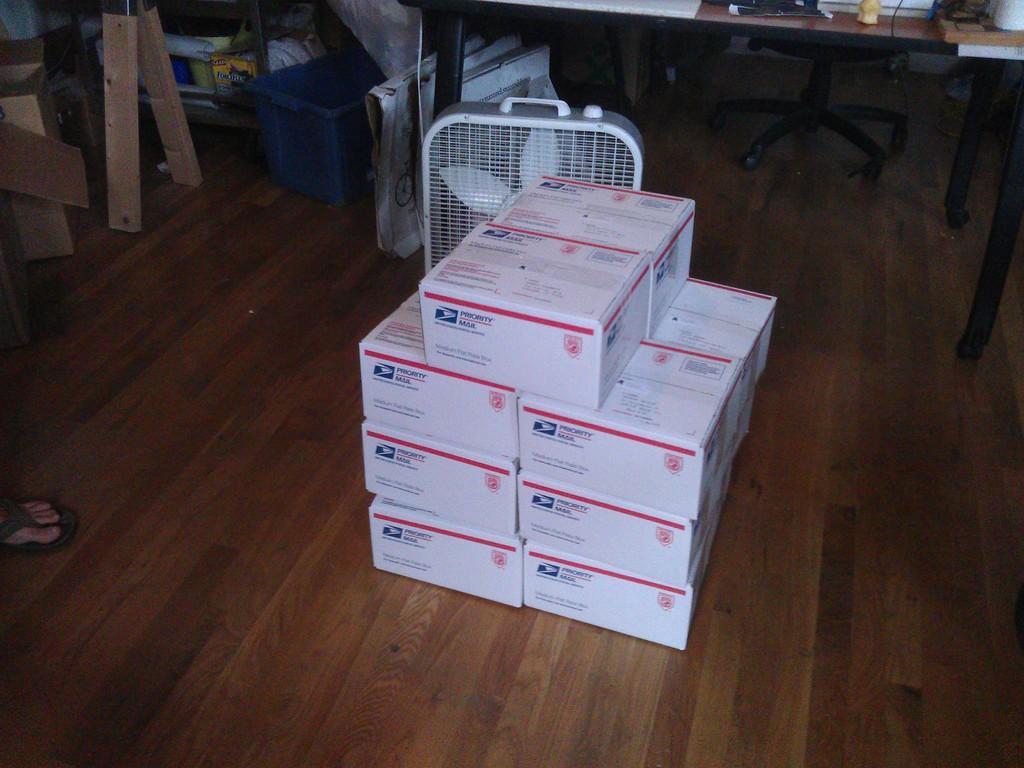Describe this image in one or two sentences. In this image there are some boxes on the floor and on the top there is a table and in the center there is one fan and on the left side there are some wooden sticks. Beside that wooden sticks there is one basket. 